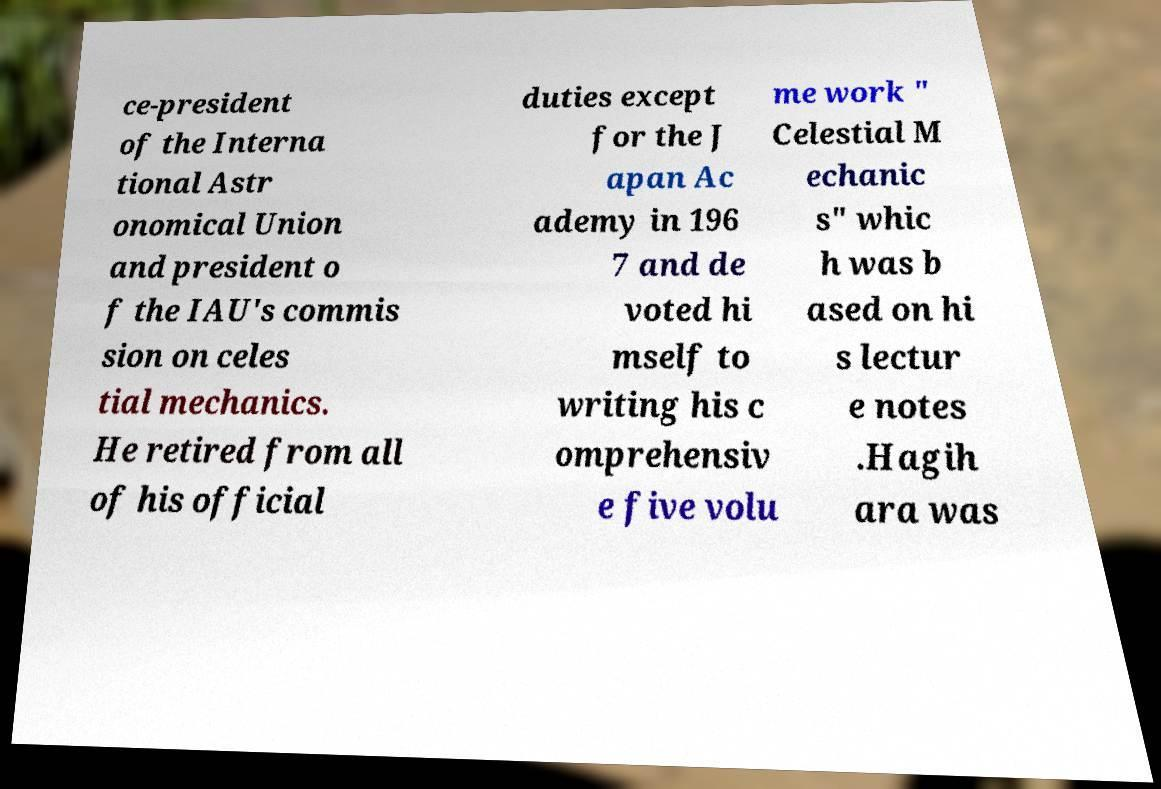There's text embedded in this image that I need extracted. Can you transcribe it verbatim? ce-president of the Interna tional Astr onomical Union and president o f the IAU's commis sion on celes tial mechanics. He retired from all of his official duties except for the J apan Ac ademy in 196 7 and de voted hi mself to writing his c omprehensiv e five volu me work " Celestial M echanic s" whic h was b ased on hi s lectur e notes .Hagih ara was 